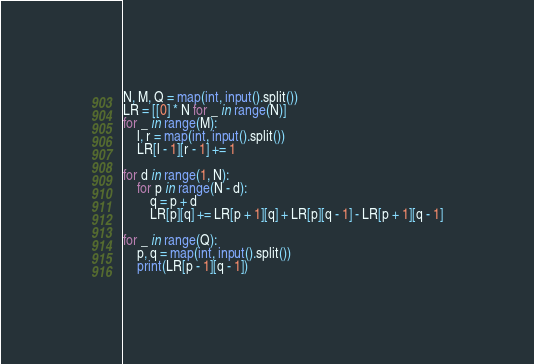<code> <loc_0><loc_0><loc_500><loc_500><_Python_>N, M, Q = map(int, input().split())
LR = [[0] * N for _ in range(N)]
for _ in range(M):
    l, r = map(int, input().split())
    LR[l - 1][r - 1] += 1

for d in range(1, N):
    for p in range(N - d):
        q = p + d
        LR[p][q] += LR[p + 1][q] + LR[p][q - 1] - LR[p + 1][q - 1]

for _ in range(Q):
    p, q = map(int, input().split())
    print(LR[p - 1][q - 1])
</code> 